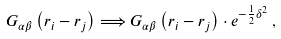<formula> <loc_0><loc_0><loc_500><loc_500>G _ { \alpha \beta } \left ( { r } _ { i } - { r } _ { j } \right ) \Longrightarrow G _ { \alpha \beta } \left ( { r } _ { i } - { r } _ { j } \right ) \cdot e ^ { - \frac { 1 } { 2 } \delta ^ { 2 } } \, ,</formula> 